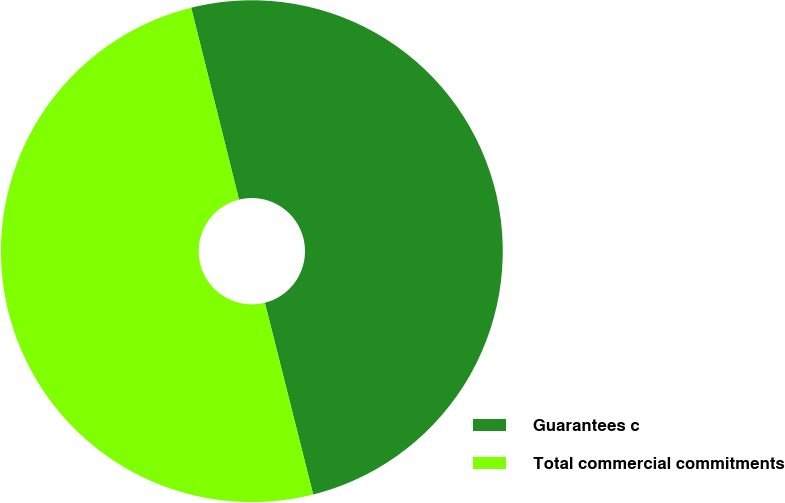<chart> <loc_0><loc_0><loc_500><loc_500><pie_chart><fcel>Guarantees c<fcel>Total commercial commitments<nl><fcel>49.96%<fcel>50.04%<nl></chart> 